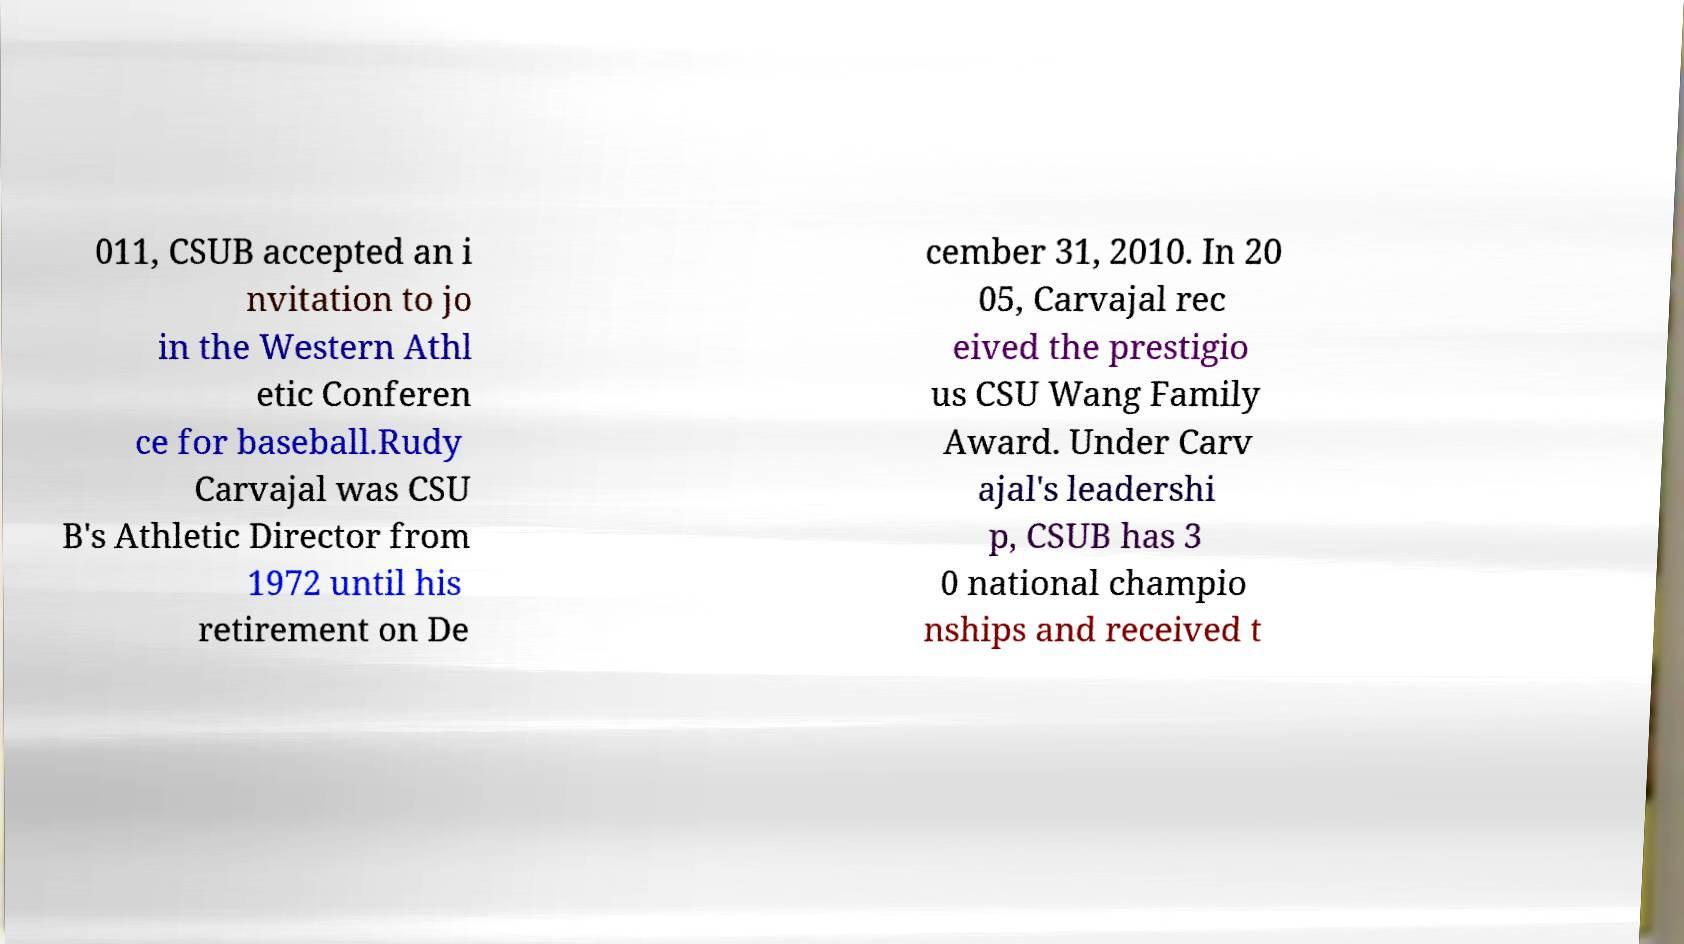What messages or text are displayed in this image? I need them in a readable, typed format. 011, CSUB accepted an i nvitation to jo in the Western Athl etic Conferen ce for baseball.Rudy Carvajal was CSU B's Athletic Director from 1972 until his retirement on De cember 31, 2010. In 20 05, Carvajal rec eived the prestigio us CSU Wang Family Award. Under Carv ajal's leadershi p, CSUB has 3 0 national champio nships and received t 